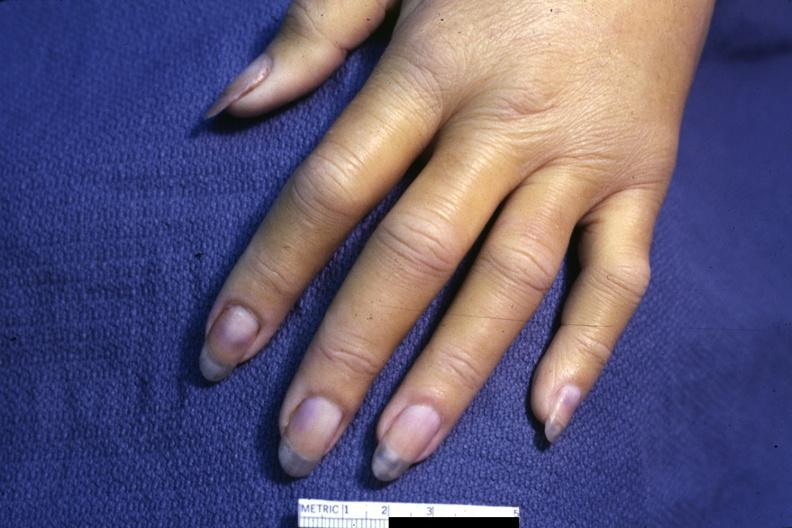does pus in test tube require dark room to see subtle distal phalangeal cyanosis?
Answer the question using a single word or phrase. No 